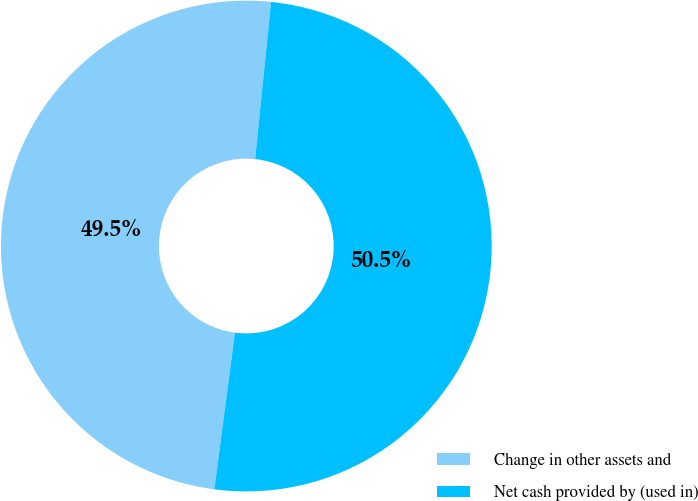Convert chart to OTSL. <chart><loc_0><loc_0><loc_500><loc_500><pie_chart><fcel>Change in other assets and<fcel>Net cash provided by (used in)<nl><fcel>49.53%<fcel>50.47%<nl></chart> 